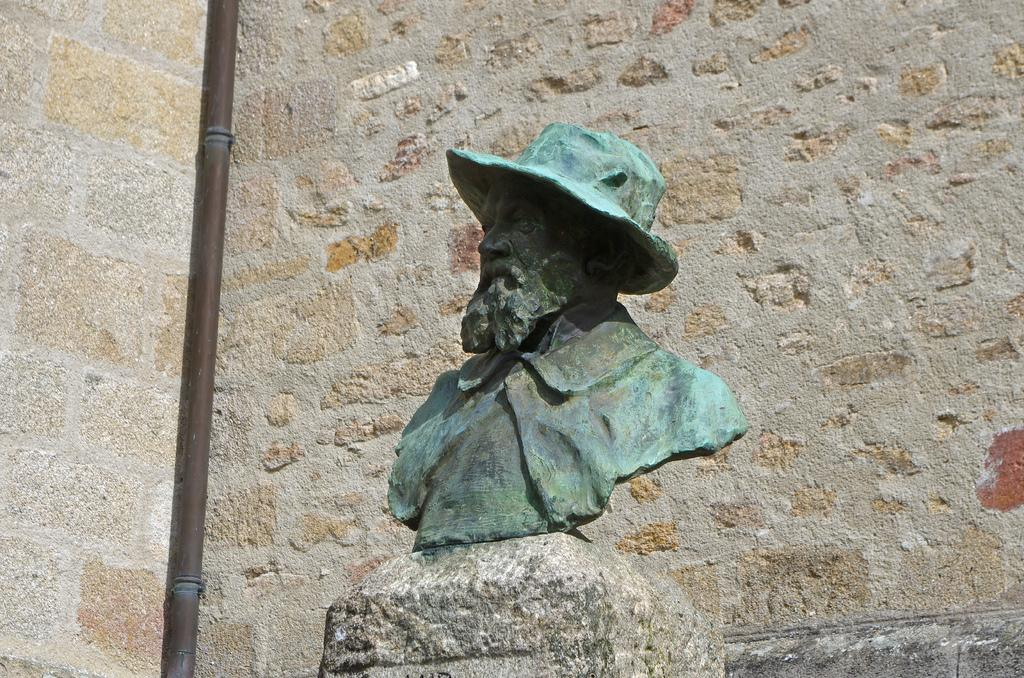What is the main subject of the image? There is a statue in the image. Where is the statue located? The statue is placed over a specific location. What else can be seen in the image besides the statue? There is a pipe present on the wall in the image. How many eggs are being held by the statue's foot in the image? There are no eggs or feet visible in the image, as it features a statue placed over a specific location and a pipe on the wall. 